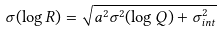Convert formula to latex. <formula><loc_0><loc_0><loc_500><loc_500>\sigma ( \log { R } ) = \sqrt { a ^ { 2 } \sigma ^ { 2 } ( \log { Q } ) + \sigma _ { i n t } ^ { 2 } }</formula> 